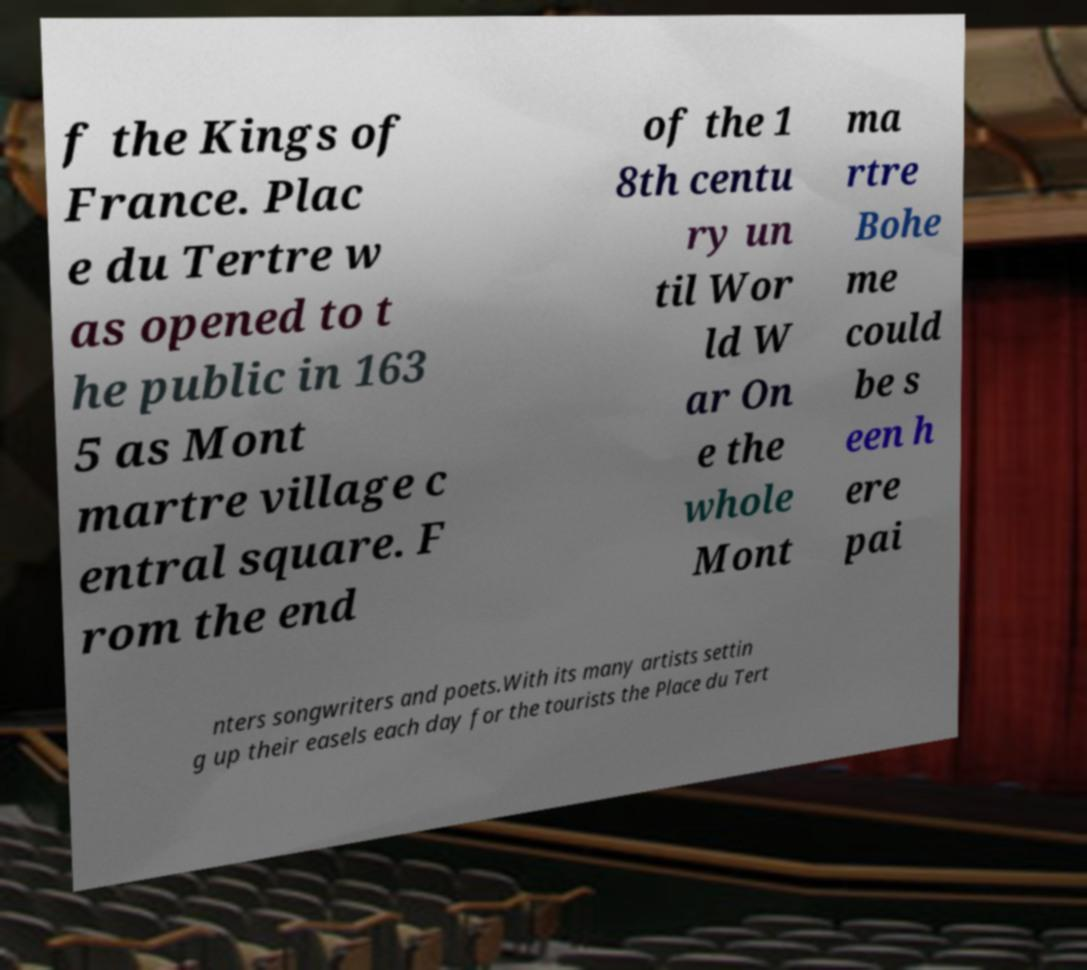Please identify and transcribe the text found in this image. f the Kings of France. Plac e du Tertre w as opened to t he public in 163 5 as Mont martre village c entral square. F rom the end of the 1 8th centu ry un til Wor ld W ar On e the whole Mont ma rtre Bohe me could be s een h ere pai nters songwriters and poets.With its many artists settin g up their easels each day for the tourists the Place du Tert 